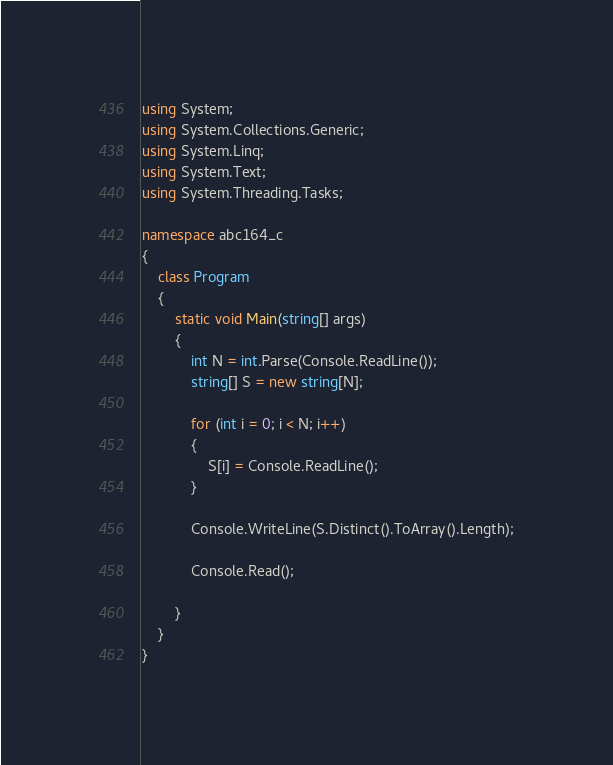Convert code to text. <code><loc_0><loc_0><loc_500><loc_500><_C#_>using System;
using System.Collections.Generic;
using System.Linq;
using System.Text;
using System.Threading.Tasks;

namespace abc164_c
{
    class Program
    {
        static void Main(string[] args)
        {
            int N = int.Parse(Console.ReadLine());
            string[] S = new string[N];

            for (int i = 0; i < N; i++)
            {
                S[i] = Console.ReadLine();
            }

            Console.WriteLine(S.Distinct().ToArray().Length);

            Console.Read();

        }
    }
}
</code> 